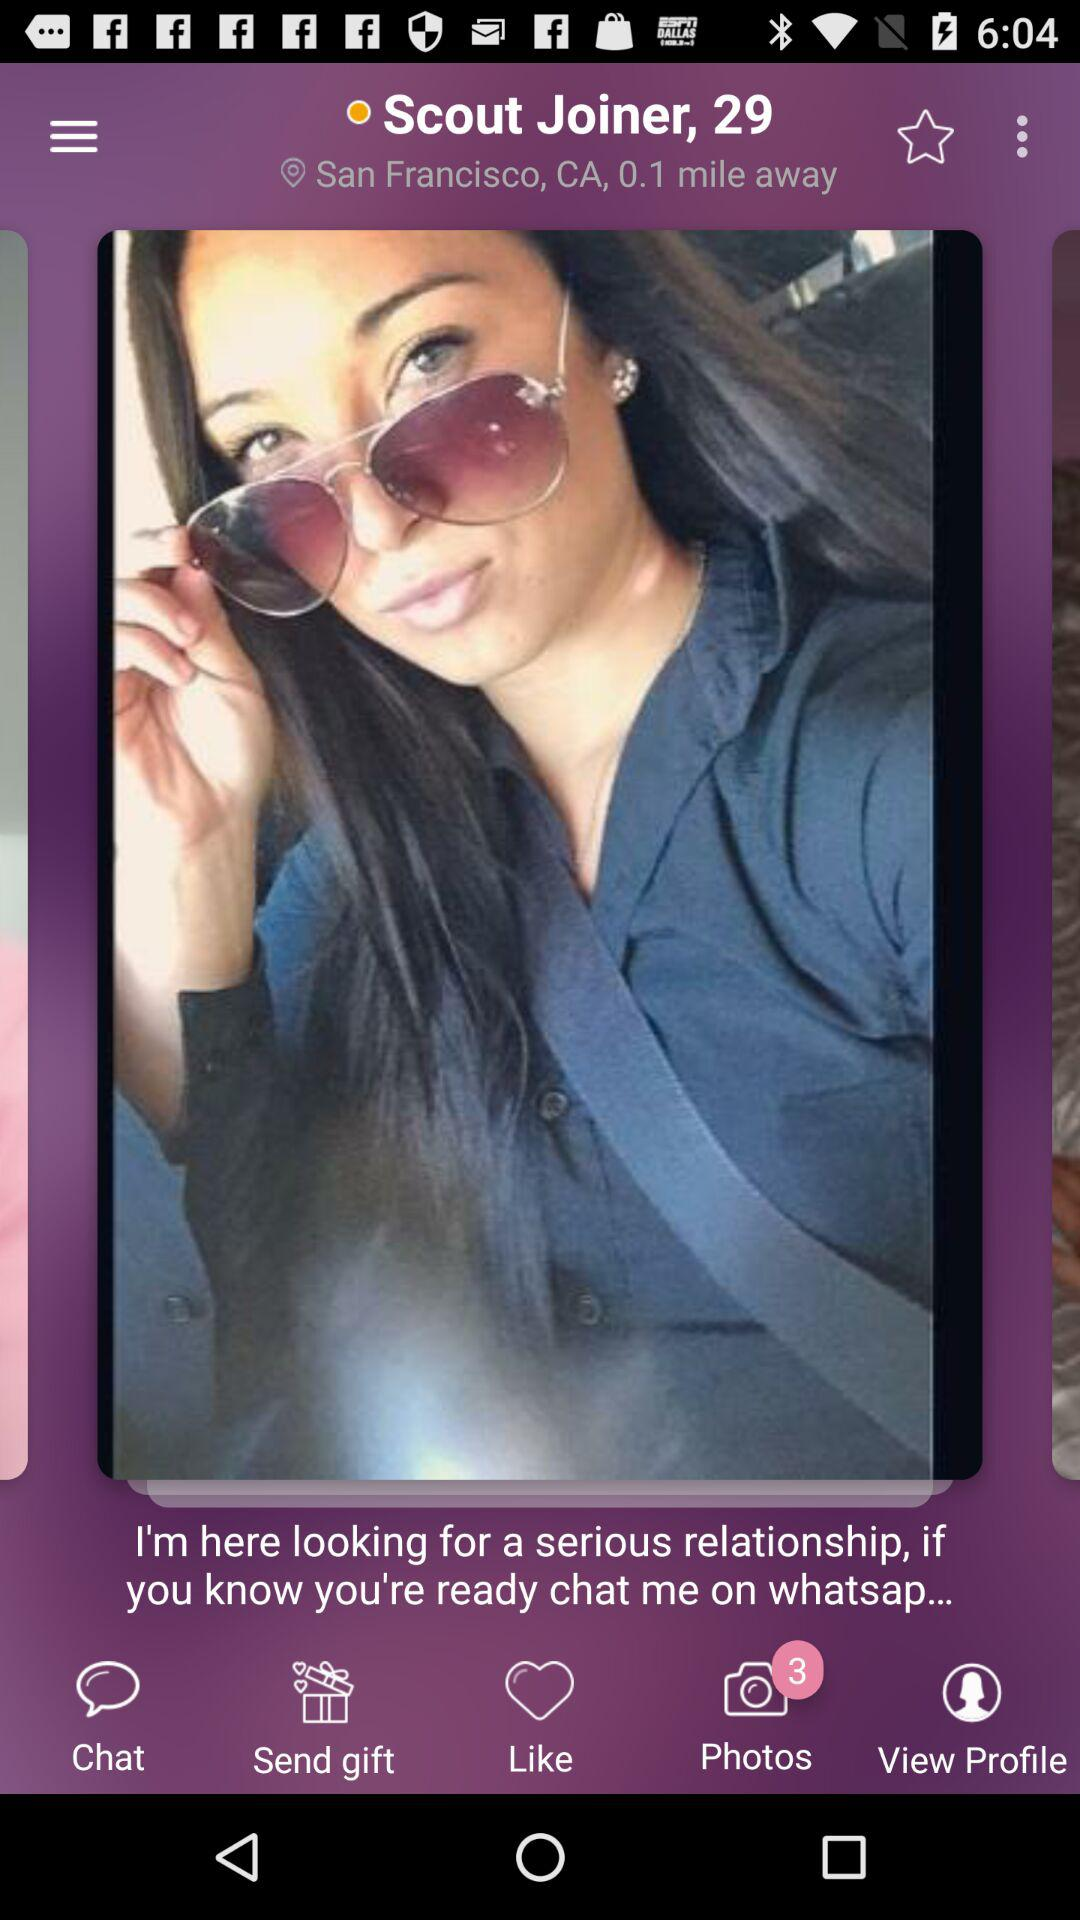How many photos does Scout have?
Answer the question using a single word or phrase. 3 